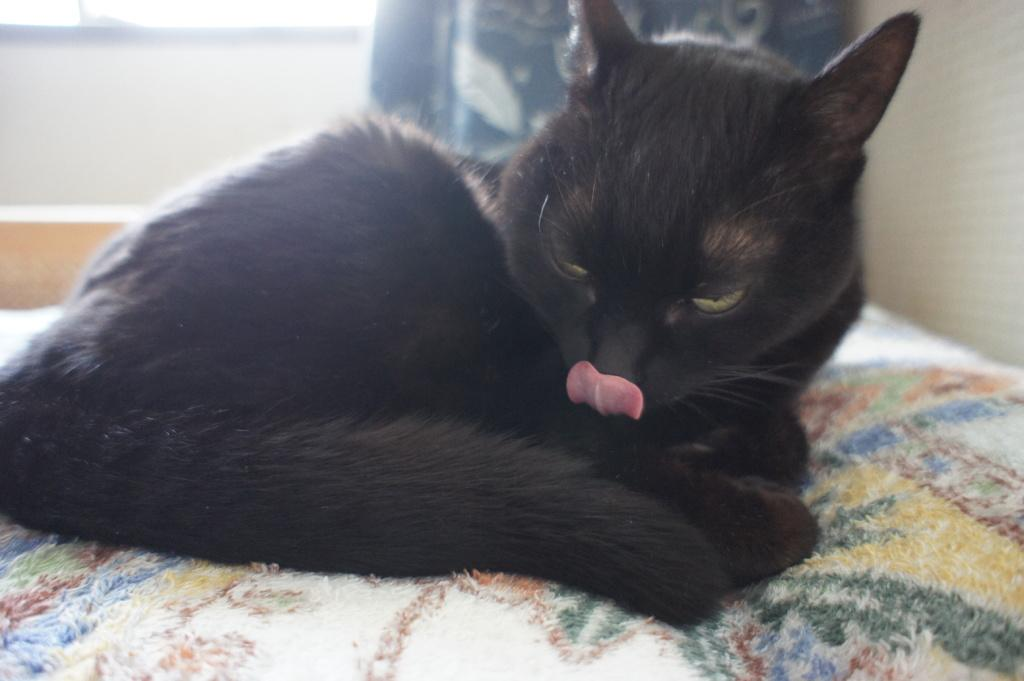What type of animal is in the image? There is a cat in the image. What color is the cat? The cat is black in color. Where is the cat located in the image? The cat is on a couch. Can you describe the couch in the image? The couch is colorful. What can be seen in the background of the image? There is a blue and white cloth in the background of the image. What type of class is being held in the image? There is no class or any indication of a class being held in the image; it features a black cat on a colorful couch. What kind of protest is taking place in the image? There is no protest or any indication of a protest in the image; it features a black cat on a colorful couch. 